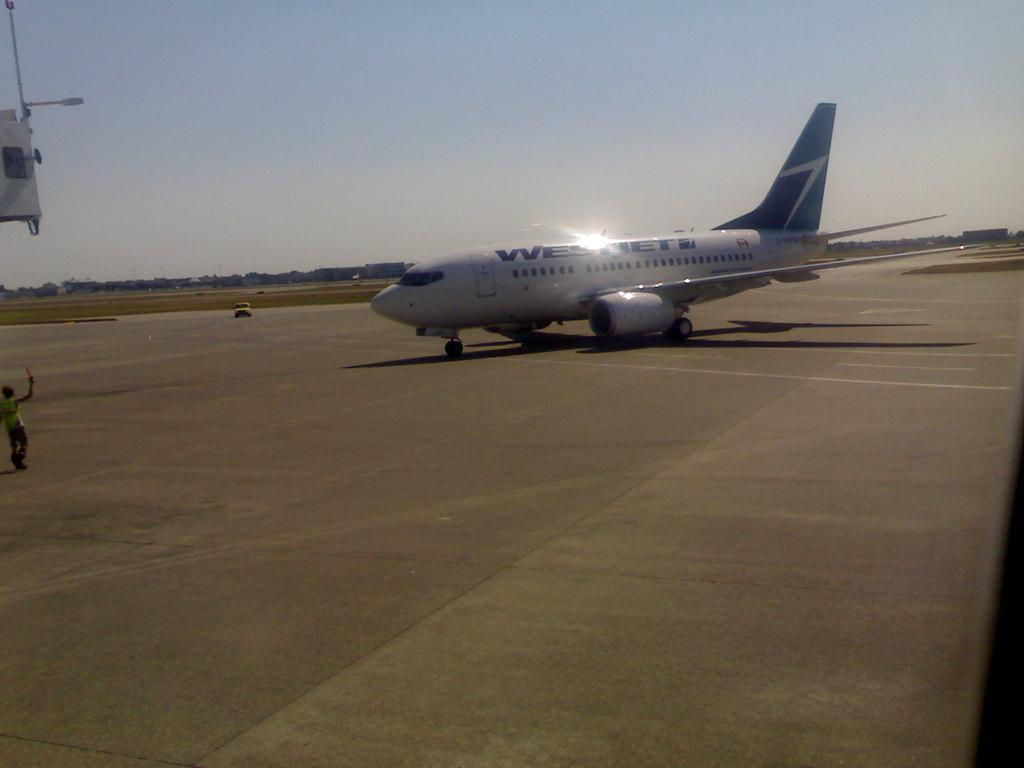<image>
Summarize the visual content of the image. West Jet is displayed on the side of the passenger plane on the tarmac. 